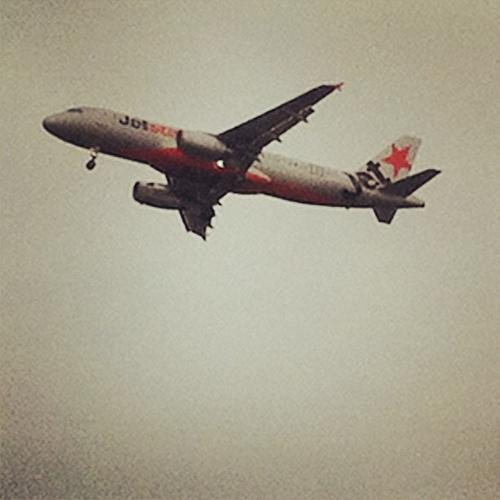Question: what color is the star?
Choices:
A. Blue.
B. Purple.
C. Silver.
D. Red.
Answer with the letter. Answer: D Question: where is the plane?
Choices:
A. At the airport.
B. In the sky.
C. In the hangar.
D. On the runway.
Answer with the letter. Answer: B Question: who is walking on the wing?
Choices:
A. No one.
B. A pilot.
C. A plane walker.
D. An acrobat.
Answer with the letter. Answer: A Question: what word is written on the plane?
Choices:
A. Jet.
B. Airline.
C. Boeing.
D. Travel.
Answer with the letter. Answer: A Question: what kind of engines on the plane?
Choices:
A. Propeller.
B. Rotor.
C. Jet.
D. Large.
Answer with the letter. Answer: C Question: how many engines are on the plane?
Choices:
A. Six.
B. Eight.
C. Two.
D. Four.
Answer with the letter. Answer: C 